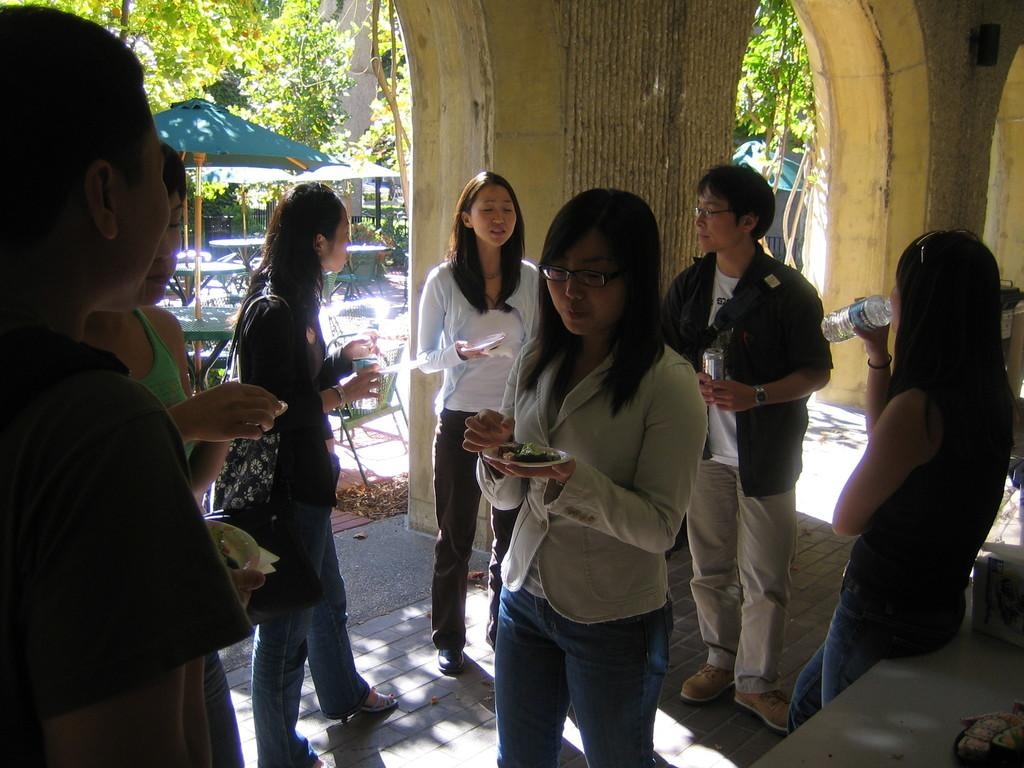What are the people in the image doing? The people in the image are standing and holding items in their hands. What can be seen in the background of the image? There are pillars, trees, huts, tables, and chairs in the background of the image. Can you see a mountain in the image? There is no mountain present in the image. What type of sand can be seen on the ground in the image? There is no sand present in the image; the ground appears to be made of a different material. 